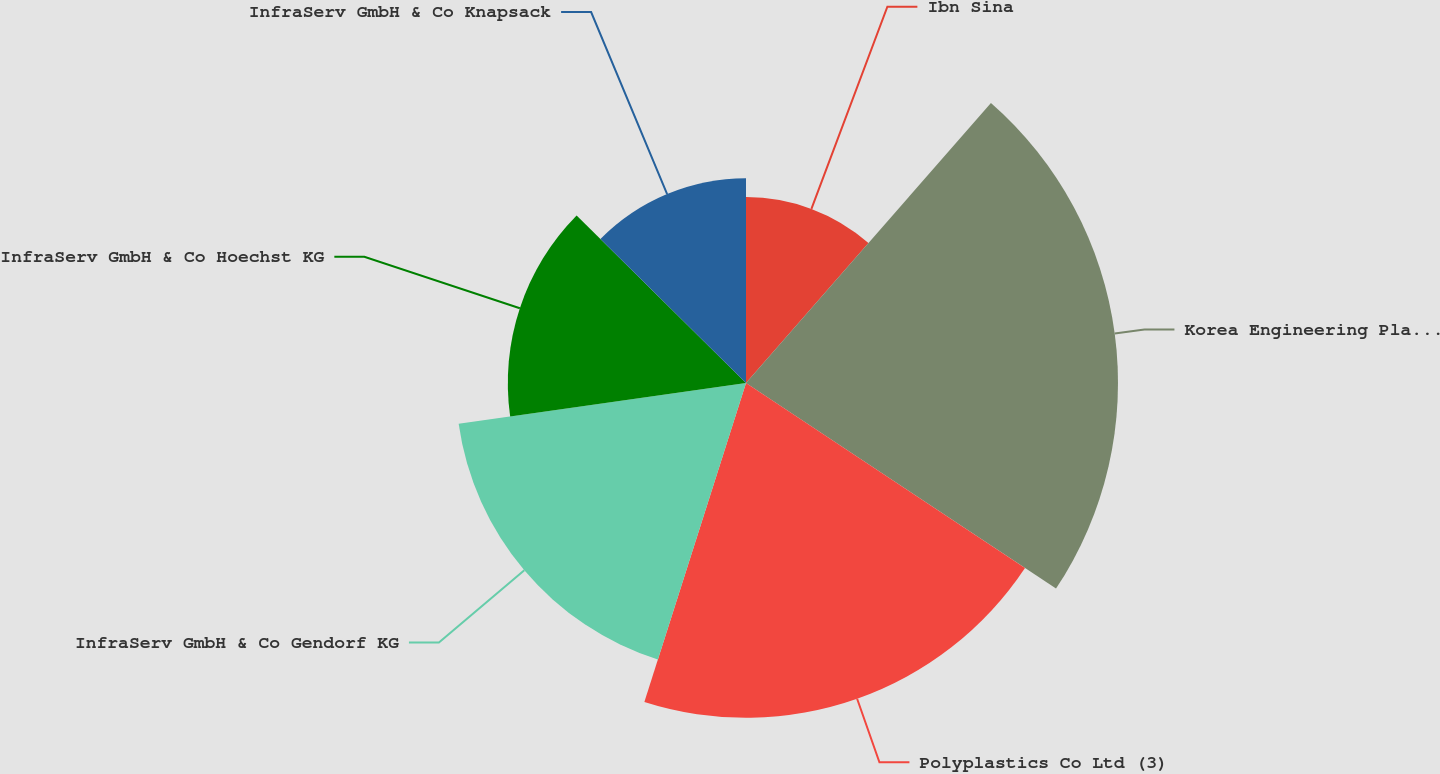Convert chart to OTSL. <chart><loc_0><loc_0><loc_500><loc_500><pie_chart><fcel>Ibn Sina<fcel>Korea Engineering Plastics Co<fcel>Polyplastics Co Ltd (3)<fcel>InfraServ GmbH & Co Gendorf KG<fcel>InfraServ GmbH & Co Hoechst KG<fcel>InfraServ GmbH & Co Knapsack<nl><fcel>11.44%<fcel>22.88%<fcel>20.59%<fcel>17.85%<fcel>14.65%<fcel>12.59%<nl></chart> 